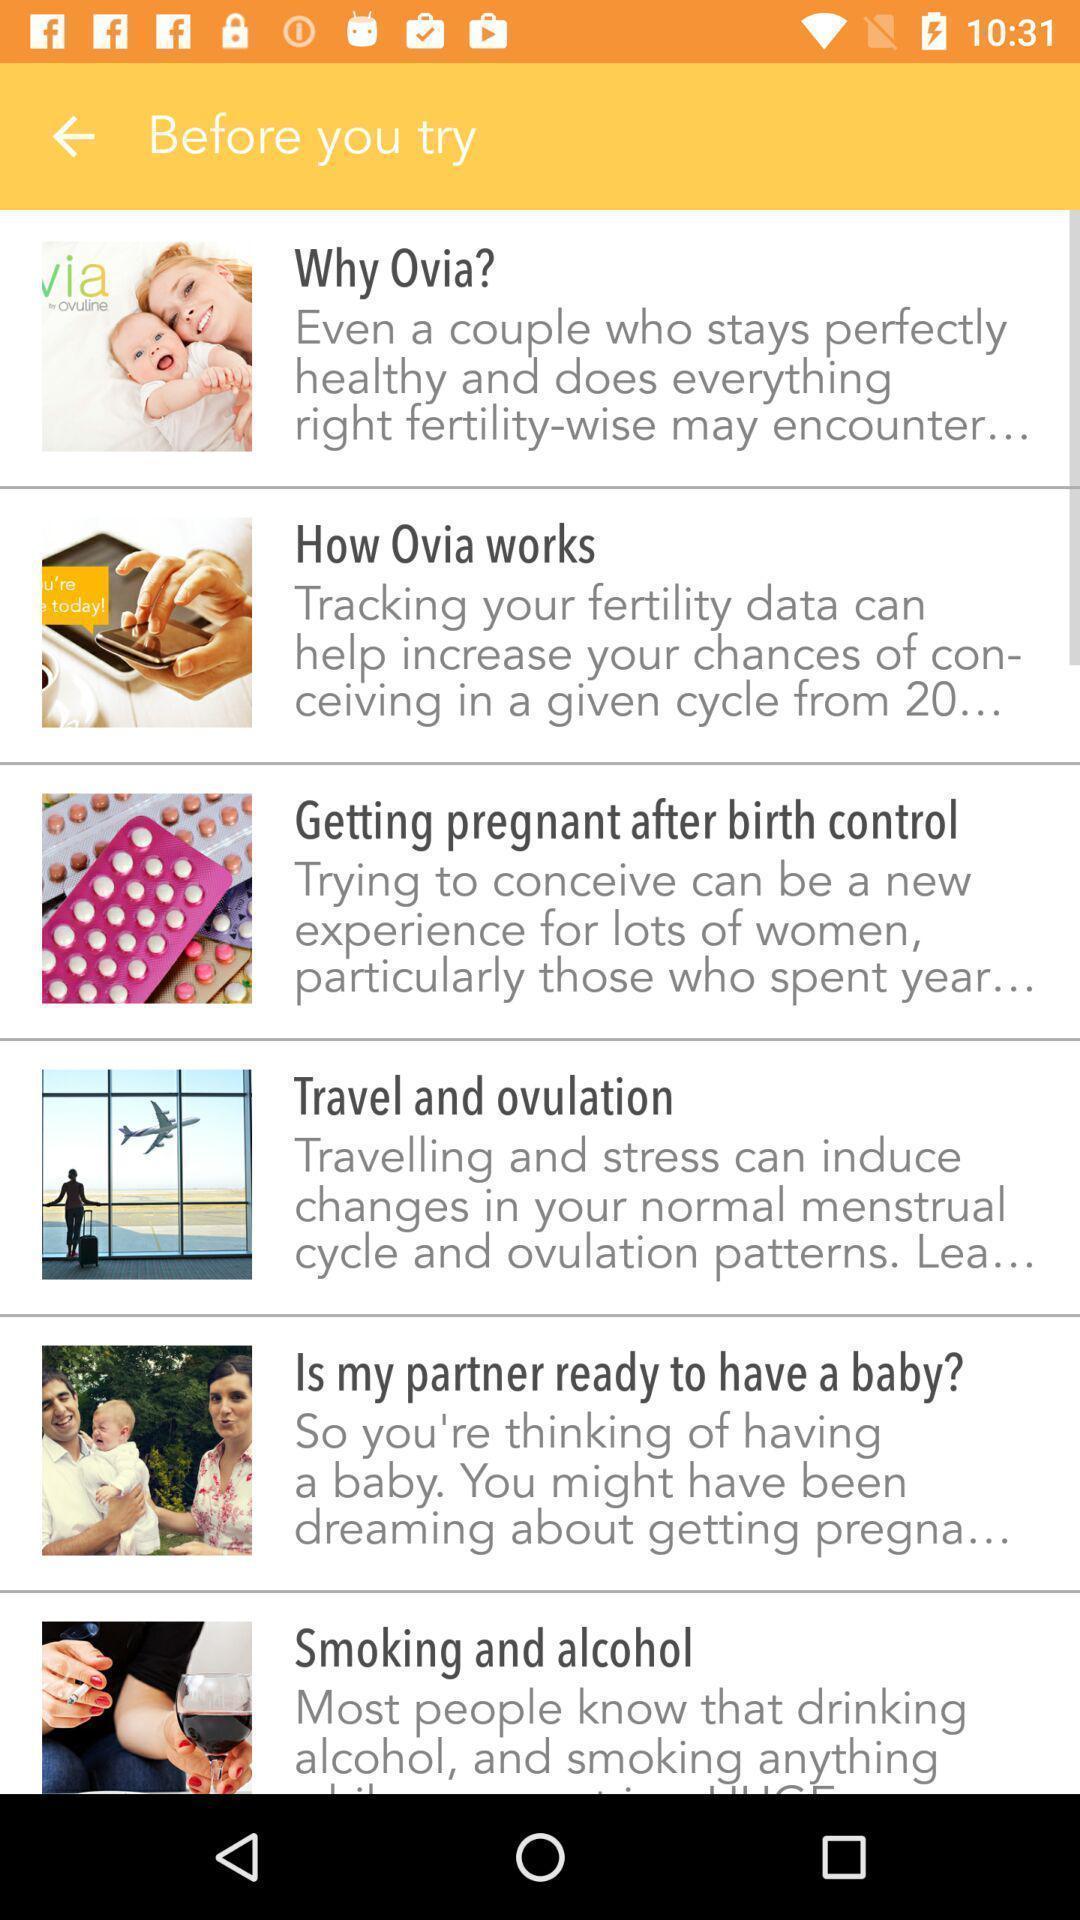Provide a textual representation of this image. Page with pregnancy information in a health care app. 